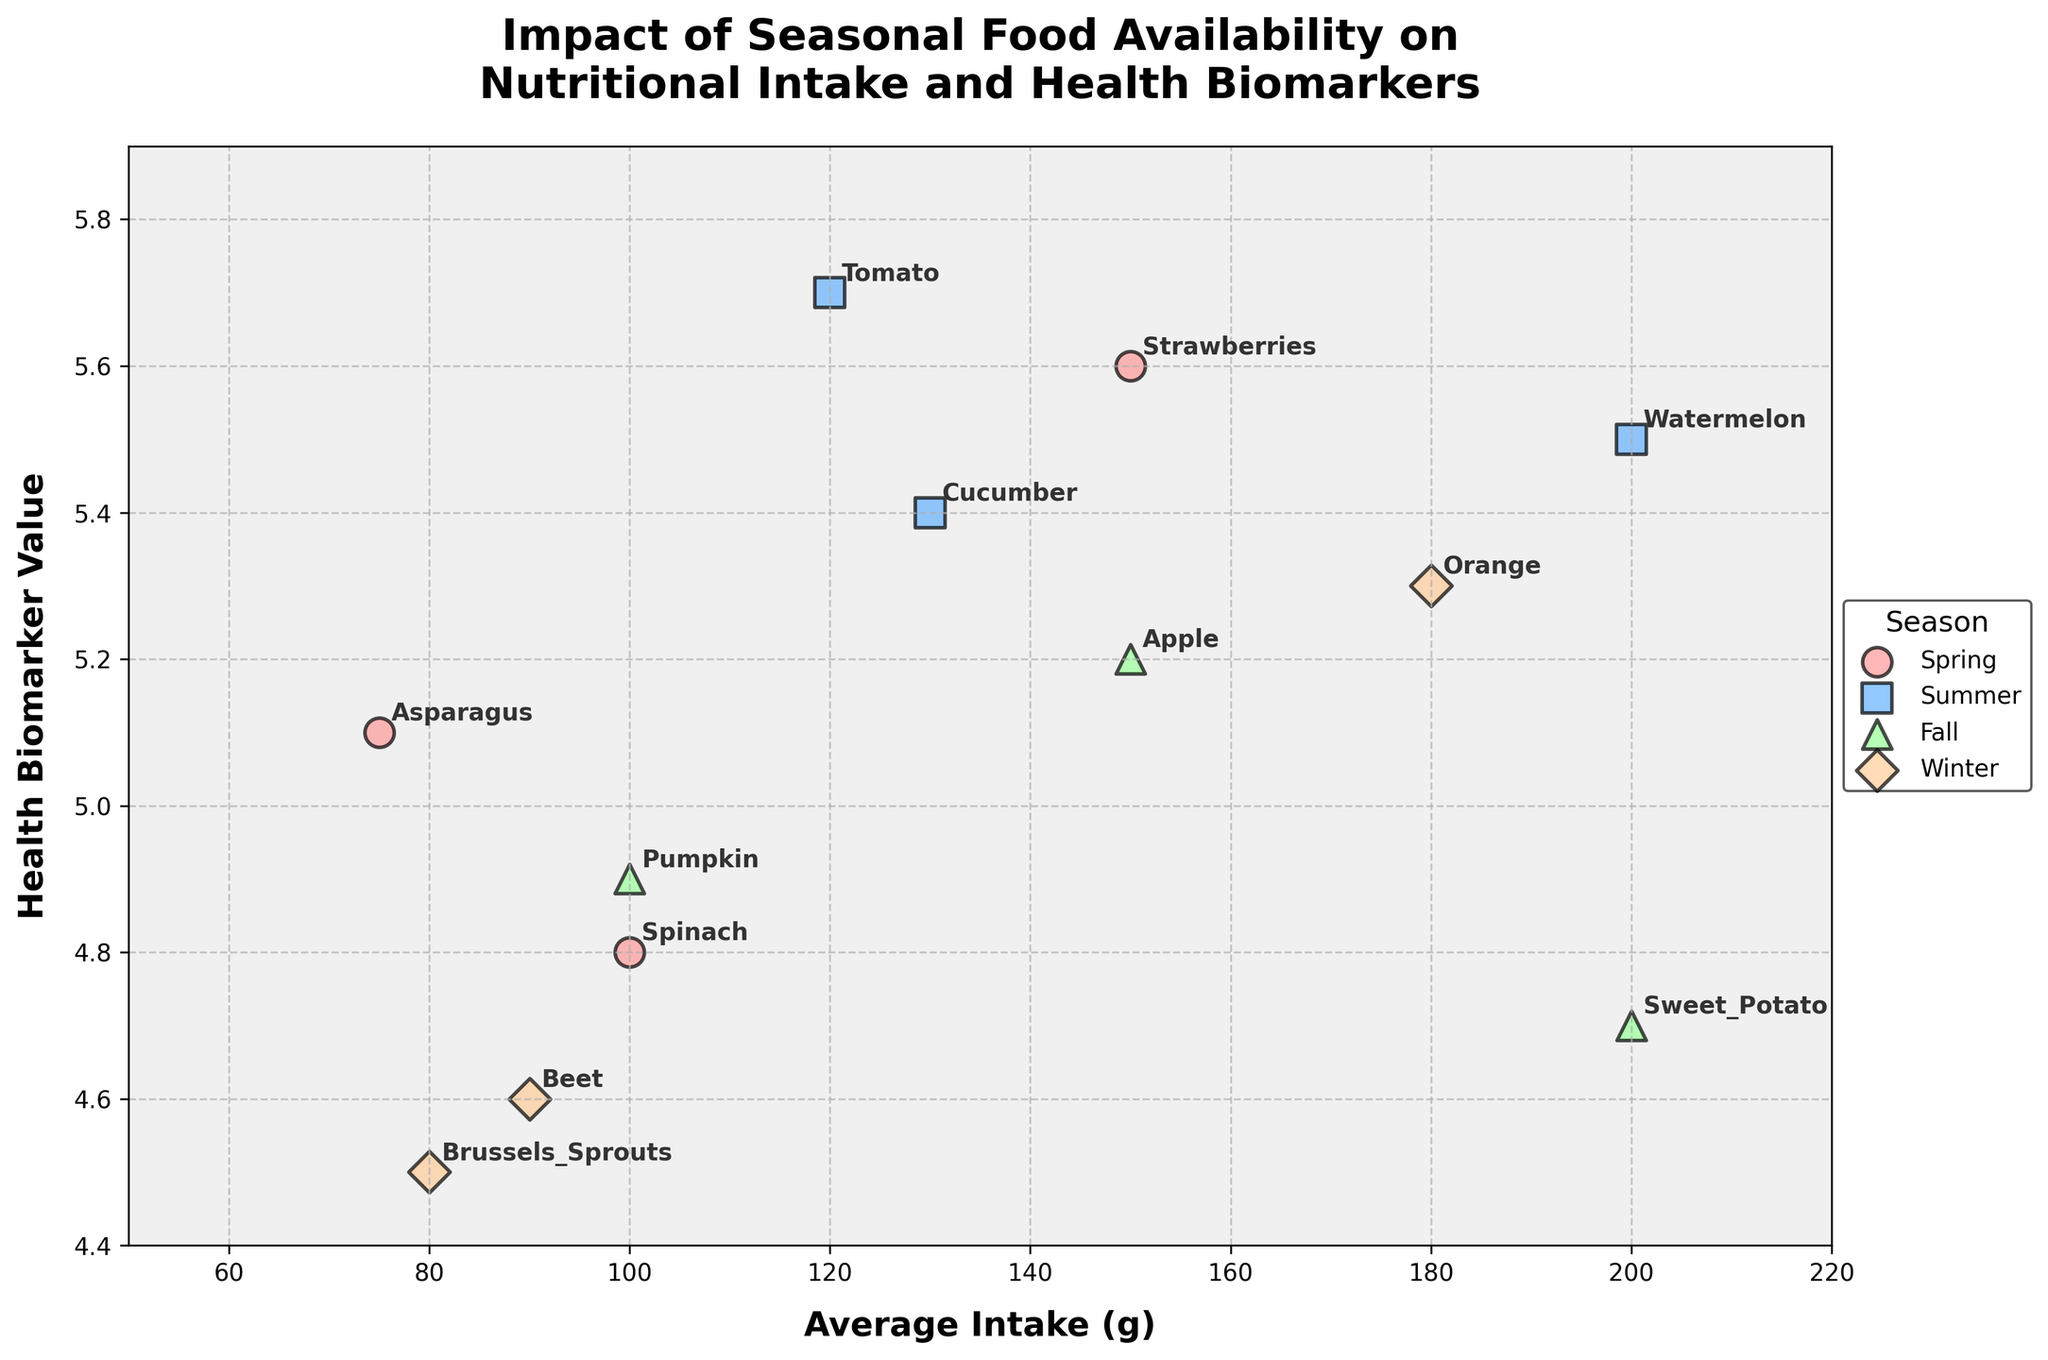What is the title of the scatter plot? The title of the scatter plot is typically displayed at the top of the figure. It helps to understand the main focus or subject of the visualization.
Answer: Impact of Seasonal Food Availability on Nutritional Intake and Health Biomarkers How many different seasons are represented in the scatter plot? By observing the legend in the figure, we can count the different categories of seasons depicted. Each season has a distinct color and marker shape.
Answer: 4 Which season has the highest average intake of any food item? To determine this, identify the food item with the maximum average intake, then check which season it belongs to based on the color and marker shape. The highest average intake is 200g for Watermelon in Summer and Sweet Potato in Fall.
Answer: Summer and Fall What is the health biomarker value for the food item with the lowest average intake? By finding the data point with the lowest average intake on the x-axis, we can observe its corresponding health biomarker value on the y-axis. The lowest intake is for Brussels Sprouts in Winter.
Answer: 4.5 Which food item in Summer season has the smallest impact on health biomarkers? Check the food items categorized under Summer and observe their health biomarker values. Identify the smallest value among them.
Answer: Cucumber How does the health biomarker value of Apple in Fall compare with Orange in Winter? By comparing the health biomarker values of Apple in Fall and Orange in Winter using their respective data points, we can determine which is higher or lower. Apple has a value of 5.2 and Orange has 5.3.
Answer: Orange is higher Which season shows the greatest variation in health biomarker values? Examine the range of health biomarker values for each season by observing the vertical spread of data points for each color and marker shape.
Answer: Winter What is the general trend between average intake and health biomarker value? By observing the overall distribution and direction of the data points, we can infer if there is a positive, negative, or no correlation between the two variables.
Answer: Slight positive correlation How does the intake of Spinach in Spring impact the health biomarker compared to Pumpkin in Fall? Locate the data points for Spinach in Spring and Pumpkin in Fall, then compare their health biomarker values and average intakes. Spinach has an intake of 100g and value of 4.8, while Pumpkin has 100g and 4.9.
Answer: Pumpkin has a slightly higher impact 